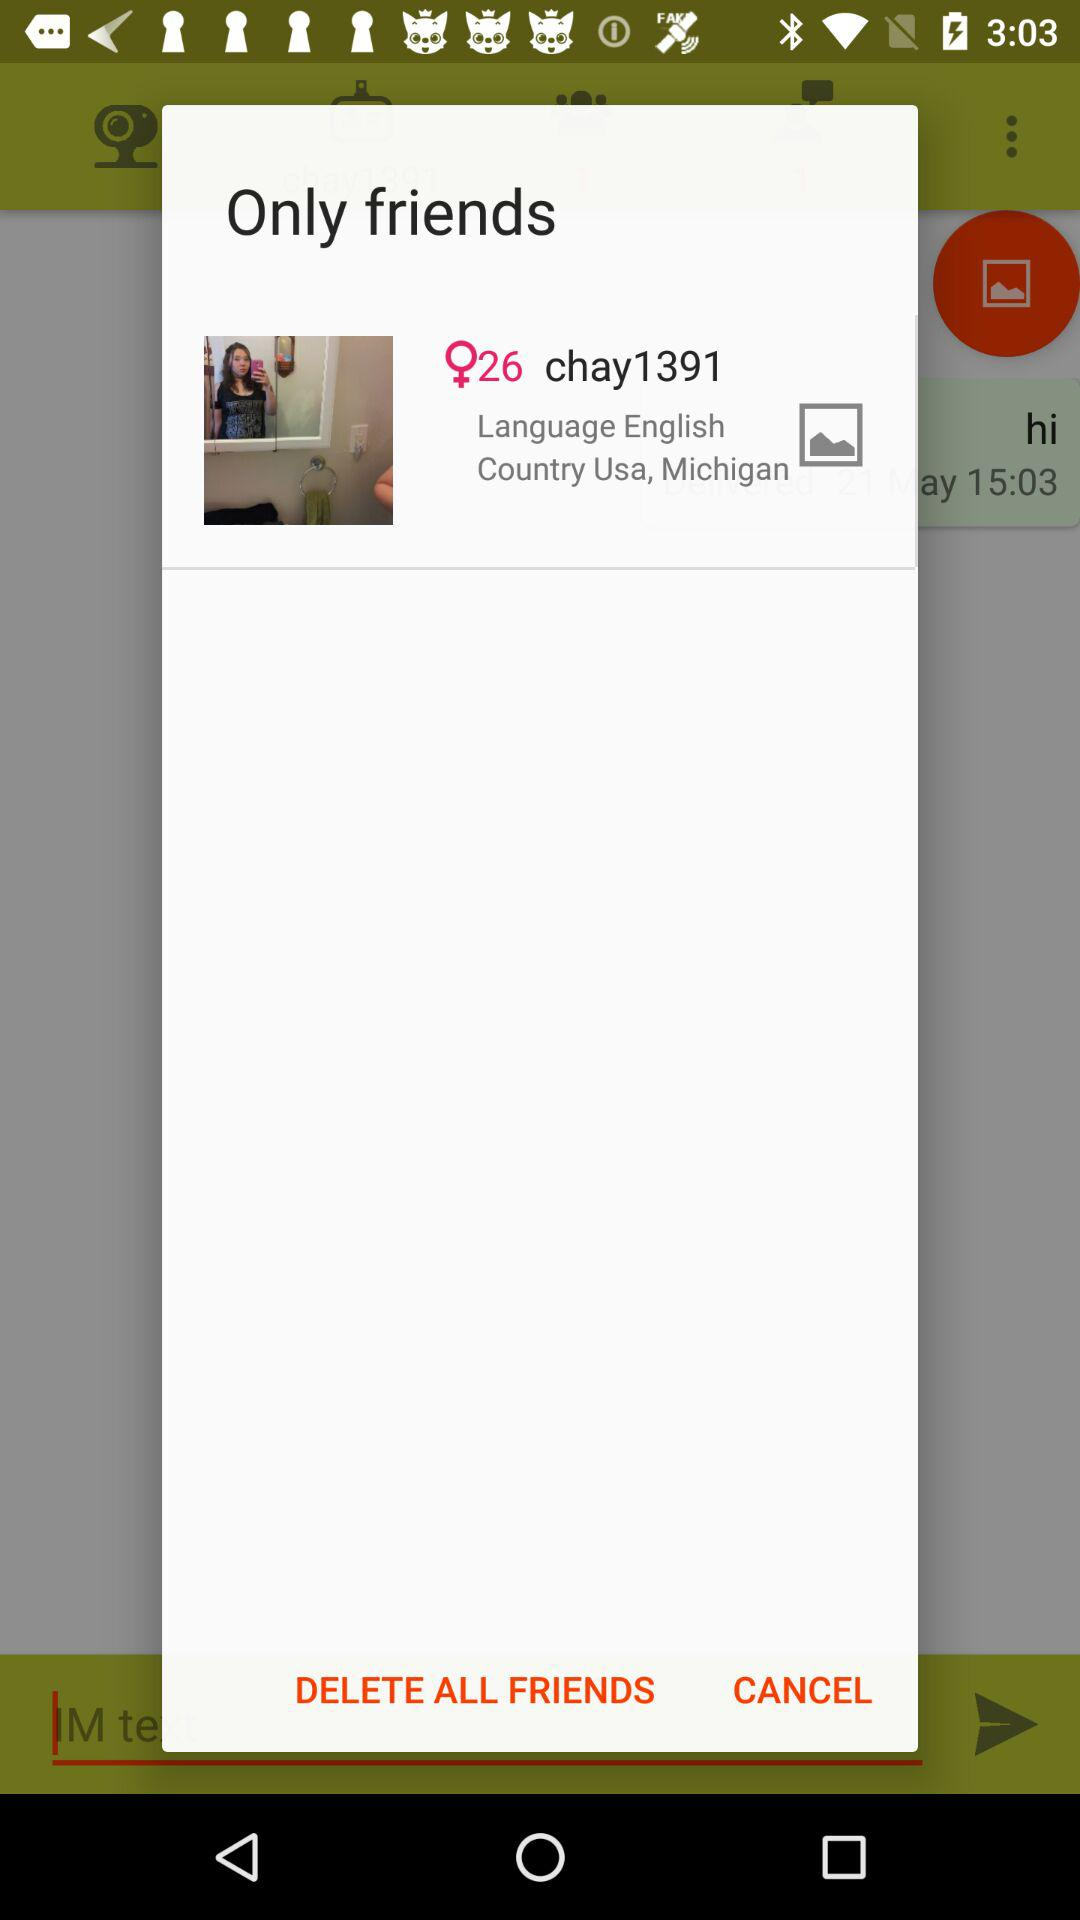What is the age? The age is 26 years. 